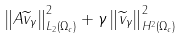<formula> <loc_0><loc_0><loc_500><loc_500>\left \| A \widetilde { v } _ { \gamma } \right \| _ { L _ { 2 } \left ( \Omega _ { c } \right ) } ^ { 2 } + \gamma \left \| \widetilde { v } _ { \gamma } \right \| _ { H ^ { 2 } \left ( \Omega _ { c } \right ) } ^ { 2 }</formula> 